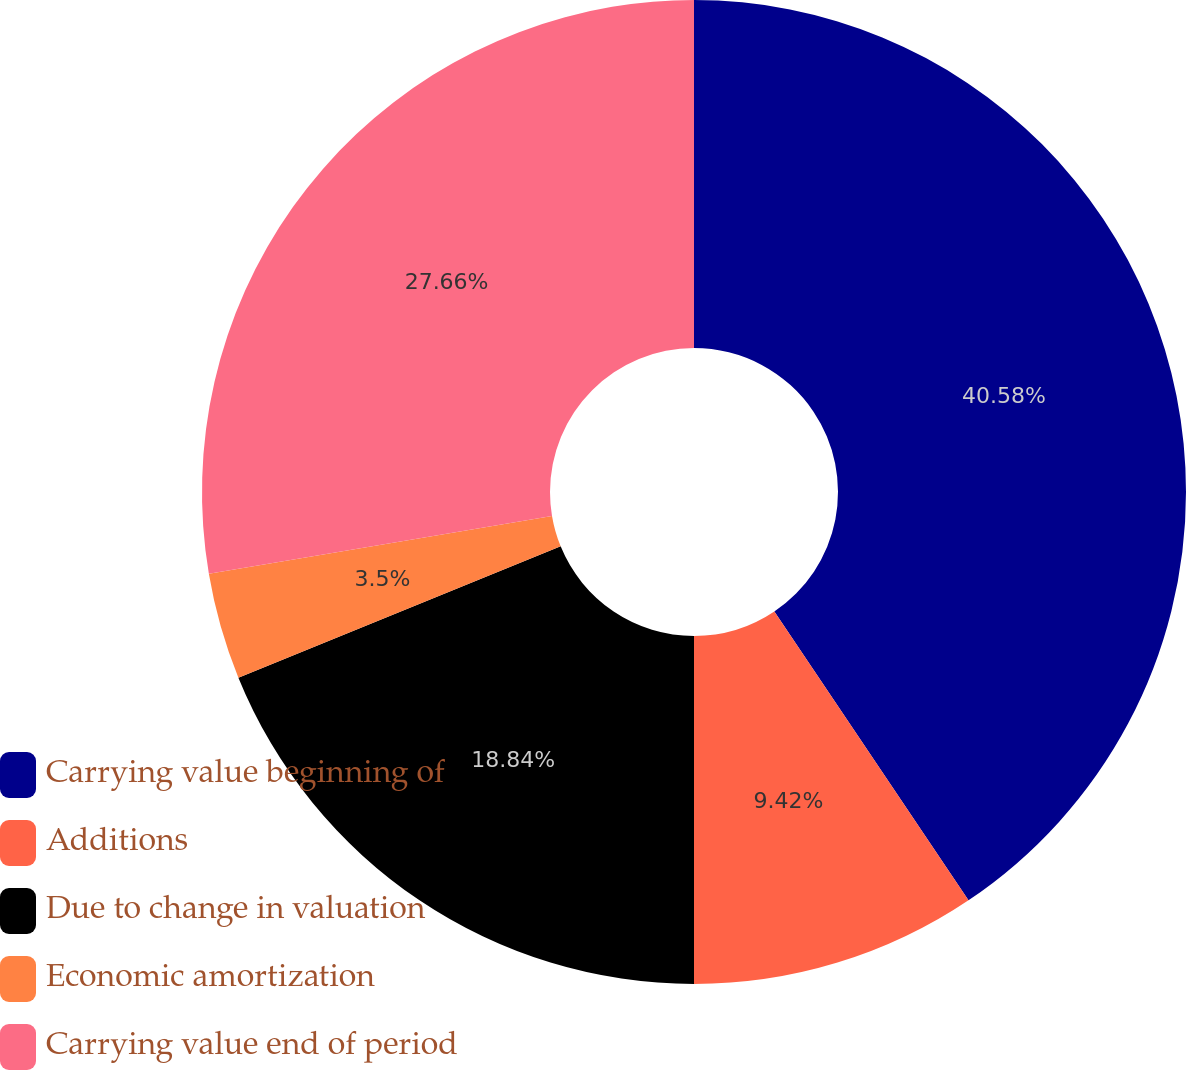<chart> <loc_0><loc_0><loc_500><loc_500><pie_chart><fcel>Carrying value beginning of<fcel>Additions<fcel>Due to change in valuation<fcel>Economic amortization<fcel>Carrying value end of period<nl><fcel>40.58%<fcel>9.42%<fcel>18.84%<fcel>3.5%<fcel>27.66%<nl></chart> 